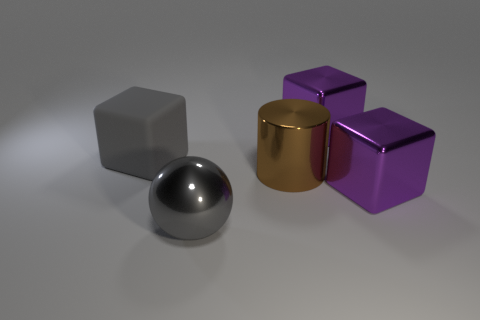How many other things are the same color as the cylinder?
Your answer should be compact. 0. There is a purple cube that is to the left of the metallic block in front of the large purple cube that is behind the gray block; what is its material?
Your answer should be compact. Metal. The big brown cylinder in front of the thing that is to the left of the shiny sphere is made of what material?
Your answer should be compact. Metal. Are there fewer large gray cubes that are in front of the brown metallic cylinder than tiny gray shiny blocks?
Your answer should be compact. No. What is the shape of the purple object that is in front of the rubber block?
Provide a short and direct response. Cube. There is a gray rubber object; is it the same size as the purple block behind the big rubber block?
Offer a terse response. Yes. Is there a big cyan cylinder made of the same material as the large gray ball?
Provide a short and direct response. No. How many spheres are large gray rubber objects or purple objects?
Your answer should be compact. 0. Is there a purple object behind the ball that is to the left of the brown shiny thing?
Your answer should be compact. Yes. Are there fewer large yellow balls than gray shiny balls?
Offer a terse response. Yes. 